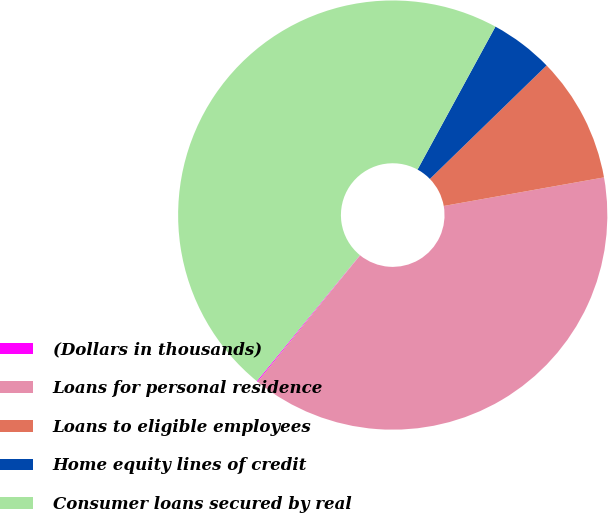Convert chart to OTSL. <chart><loc_0><loc_0><loc_500><loc_500><pie_chart><fcel>(Dollars in thousands)<fcel>Loans for personal residence<fcel>Loans to eligible employees<fcel>Home equity lines of credit<fcel>Consumer loans secured by real<nl><fcel>0.08%<fcel>38.64%<fcel>9.47%<fcel>4.78%<fcel>47.03%<nl></chart> 